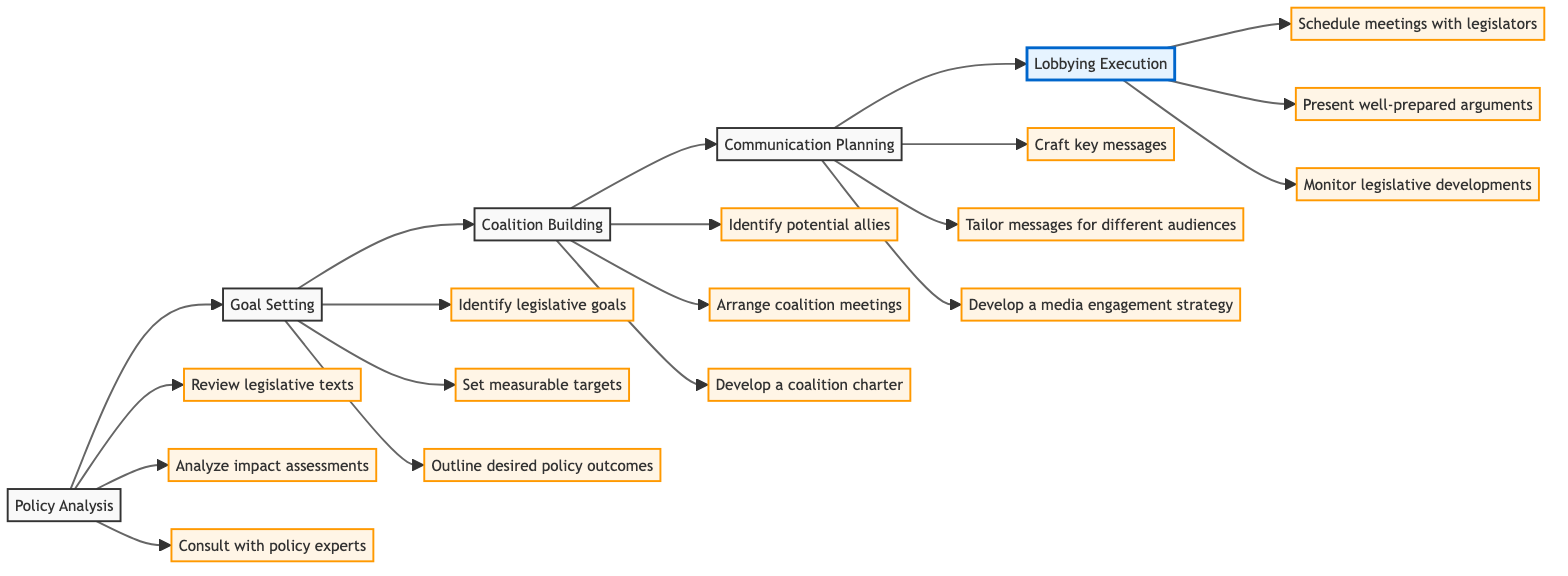What is the first step in the advocacy strategy? The first step in the advocacy strategy is indicated by the first node on the flowchart, which is “Policy Analysis.”
Answer: Policy Analysis How many actions are listed under Goal Setting? By examining the Goal Setting section, I can count three actions listed: "Identify legislative goals," "Set measurable targets," and "Outline desired policy outcomes."
Answer: 3 What is the last step in the outlined strategy? The last step is represented by the last node in the diagram, which is “Lobbying Execution.”
Answer: Lobbying Execution Which step directly follows Coalition Building? The flowchart indicates an arrow from the "Coalition Building" node to the "Communication Planning" node, meaning Communication Planning directly follows Coalition Building.
Answer: Communication Planning What actions are included in the Communication Planning step? The actions under the Communication Planning step are "Craft key messages," "Tailor messages for different audiences," and "Develop a media engagement strategy."
Answer: Craft key messages, Tailor messages for different audiences, Develop a media engagement strategy Which step comes before Goal Setting? The flowchart shows an arrow leading into the "Goal Setting" node from the "Policy Analysis" node, indicating that Policy Analysis comes before Goal Setting.
Answer: Policy Analysis How many total steps are in the advocacy strategy? There are five steps illustrated in the diagram: Policy Analysis, Goal Setting, Coalition Building, Communication Planning, and Lobbying Execution.
Answer: 5 What is the primary purpose of Coalition Building? The description under Coalition Building states that its purpose is to "Form alliances with other stakeholders to strengthen the advocacy campaign," indicating that building alliances is the primary aim.
Answer: Form alliances with other stakeholders to strengthen the advocacy campaign How many actions are listed under Lobbying Execution? The actions listed under Lobbying Execution include "Schedule meetings with legislators," "Present well-prepared arguments," and "Monitor legislative developments," amounting to three total actions.
Answer: 3 